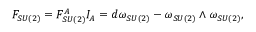Convert formula to latex. <formula><loc_0><loc_0><loc_500><loc_500>F _ { S U ( 2 ) } = F _ { S U ( 2 ) } ^ { A } I _ { A } = d \omega _ { S U ( 2 ) } - \omega _ { S U ( 2 ) } \wedge \omega _ { S U ( 2 ) } ,</formula> 